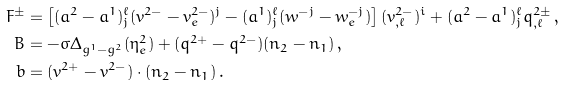Convert formula to latex. <formula><loc_0><loc_0><loc_500><loc_500>F ^ { \pm } & = \left [ ( a ^ { 2 } - a ^ { 1 } ) _ { j } ^ { \ell } ( v ^ { 2 - } - v ^ { 2 - } _ { e } ) ^ { j } - ( a ^ { 1 } ) _ { j } ^ { \ell } ( w ^ { - j } - w ^ { - j } _ { e } ) \right ] ( v ^ { 2 - } _ { , \ell } ) ^ { i } + ( a ^ { 2 } - a ^ { 1 } ) _ { j } ^ { \ell } q ^ { 2 \pm } _ { , \ell } \, , \\ B & = - \sigma \Delta _ { g ^ { 1 } - g ^ { 2 } } ( \eta _ { e } ^ { 2 } ) + ( q ^ { 2 + } - q ^ { 2 - } ) ( n _ { 2 } - n _ { 1 } ) \, , \\ b & = ( v ^ { 2 + } - v ^ { 2 - } ) \cdot ( n _ { 2 } - n _ { 1 } ) \, .</formula> 